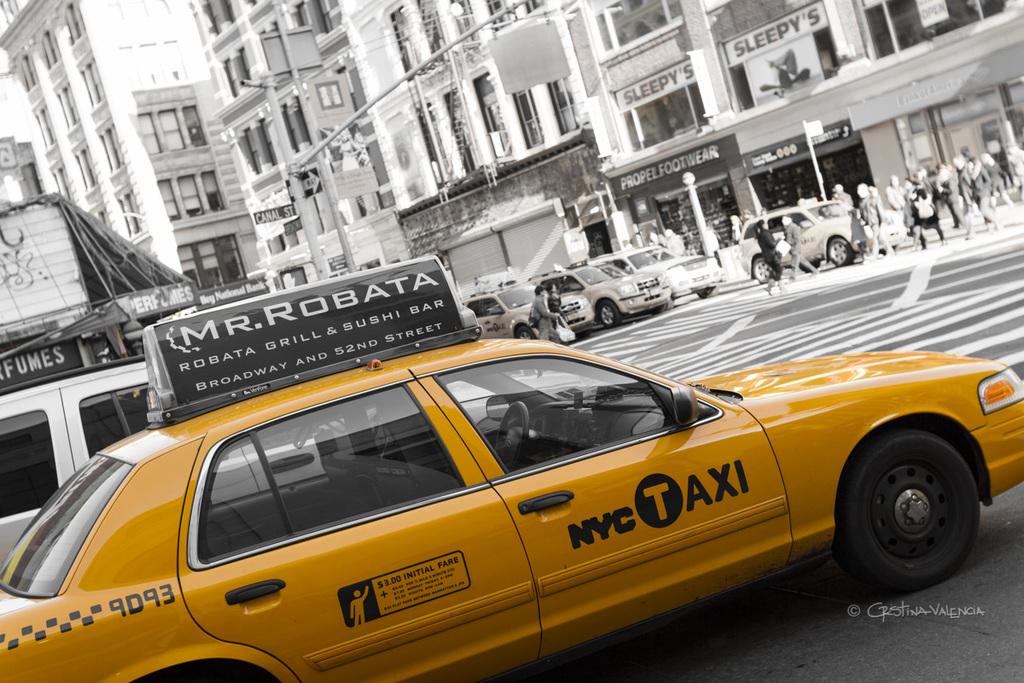What is this city?
Provide a succinct answer. Nyc. This some book?
Make the answer very short. No. 